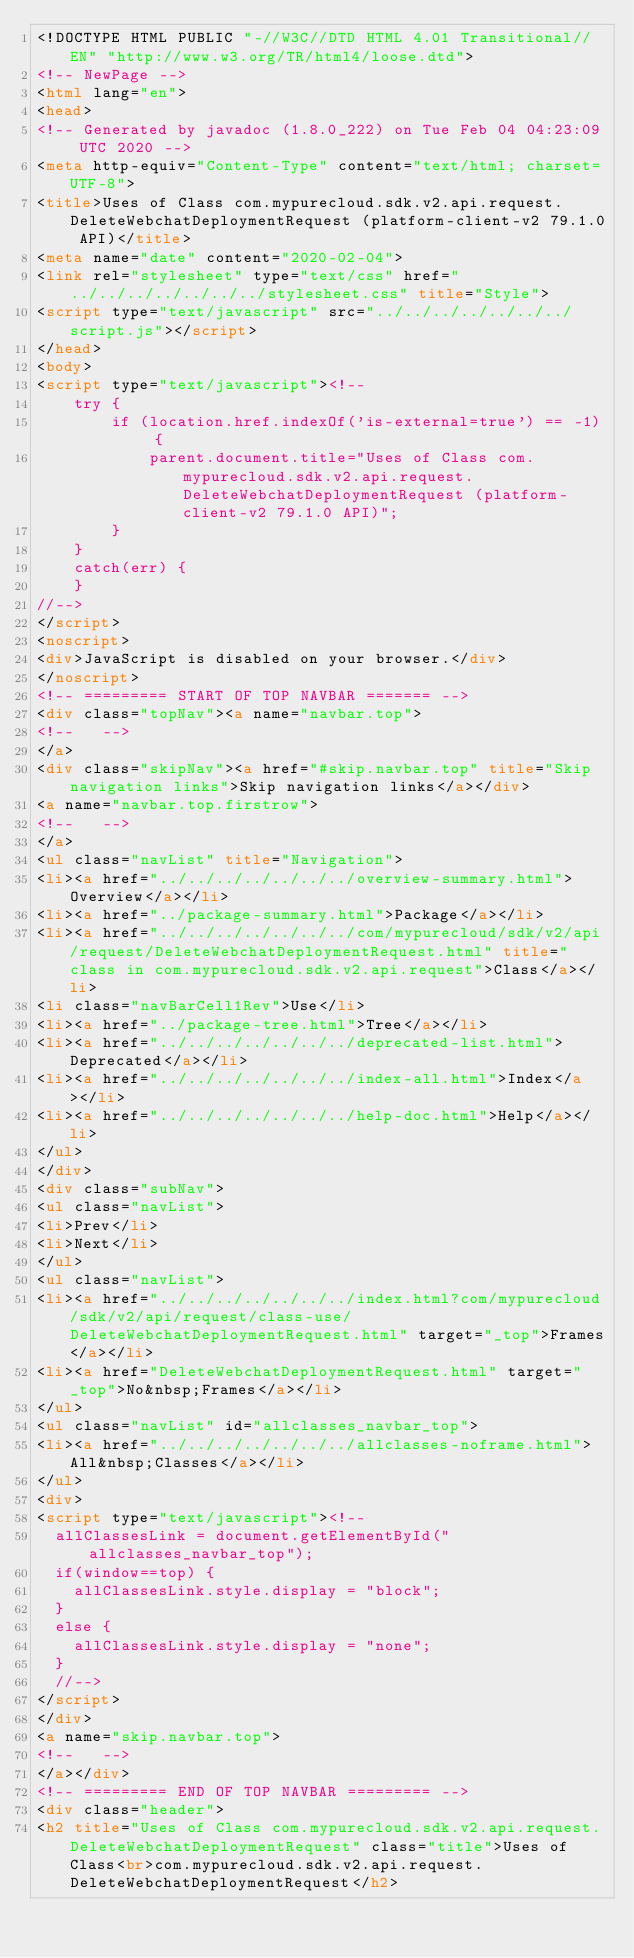Convert code to text. <code><loc_0><loc_0><loc_500><loc_500><_HTML_><!DOCTYPE HTML PUBLIC "-//W3C//DTD HTML 4.01 Transitional//EN" "http://www.w3.org/TR/html4/loose.dtd">
<!-- NewPage -->
<html lang="en">
<head>
<!-- Generated by javadoc (1.8.0_222) on Tue Feb 04 04:23:09 UTC 2020 -->
<meta http-equiv="Content-Type" content="text/html; charset=UTF-8">
<title>Uses of Class com.mypurecloud.sdk.v2.api.request.DeleteWebchatDeploymentRequest (platform-client-v2 79.1.0 API)</title>
<meta name="date" content="2020-02-04">
<link rel="stylesheet" type="text/css" href="../../../../../../../stylesheet.css" title="Style">
<script type="text/javascript" src="../../../../../../../script.js"></script>
</head>
<body>
<script type="text/javascript"><!--
    try {
        if (location.href.indexOf('is-external=true') == -1) {
            parent.document.title="Uses of Class com.mypurecloud.sdk.v2.api.request.DeleteWebchatDeploymentRequest (platform-client-v2 79.1.0 API)";
        }
    }
    catch(err) {
    }
//-->
</script>
<noscript>
<div>JavaScript is disabled on your browser.</div>
</noscript>
<!-- ========= START OF TOP NAVBAR ======= -->
<div class="topNav"><a name="navbar.top">
<!--   -->
</a>
<div class="skipNav"><a href="#skip.navbar.top" title="Skip navigation links">Skip navigation links</a></div>
<a name="navbar.top.firstrow">
<!--   -->
</a>
<ul class="navList" title="Navigation">
<li><a href="../../../../../../../overview-summary.html">Overview</a></li>
<li><a href="../package-summary.html">Package</a></li>
<li><a href="../../../../../../../com/mypurecloud/sdk/v2/api/request/DeleteWebchatDeploymentRequest.html" title="class in com.mypurecloud.sdk.v2.api.request">Class</a></li>
<li class="navBarCell1Rev">Use</li>
<li><a href="../package-tree.html">Tree</a></li>
<li><a href="../../../../../../../deprecated-list.html">Deprecated</a></li>
<li><a href="../../../../../../../index-all.html">Index</a></li>
<li><a href="../../../../../../../help-doc.html">Help</a></li>
</ul>
</div>
<div class="subNav">
<ul class="navList">
<li>Prev</li>
<li>Next</li>
</ul>
<ul class="navList">
<li><a href="../../../../../../../index.html?com/mypurecloud/sdk/v2/api/request/class-use/DeleteWebchatDeploymentRequest.html" target="_top">Frames</a></li>
<li><a href="DeleteWebchatDeploymentRequest.html" target="_top">No&nbsp;Frames</a></li>
</ul>
<ul class="navList" id="allclasses_navbar_top">
<li><a href="../../../../../../../allclasses-noframe.html">All&nbsp;Classes</a></li>
</ul>
<div>
<script type="text/javascript"><!--
  allClassesLink = document.getElementById("allclasses_navbar_top");
  if(window==top) {
    allClassesLink.style.display = "block";
  }
  else {
    allClassesLink.style.display = "none";
  }
  //-->
</script>
</div>
<a name="skip.navbar.top">
<!--   -->
</a></div>
<!-- ========= END OF TOP NAVBAR ========= -->
<div class="header">
<h2 title="Uses of Class com.mypurecloud.sdk.v2.api.request.DeleteWebchatDeploymentRequest" class="title">Uses of Class<br>com.mypurecloud.sdk.v2.api.request.DeleteWebchatDeploymentRequest</h2></code> 